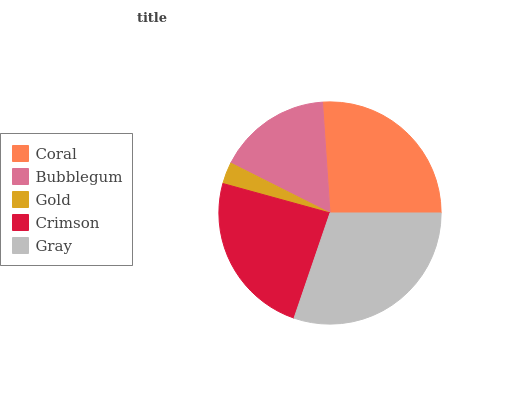Is Gold the minimum?
Answer yes or no. Yes. Is Gray the maximum?
Answer yes or no. Yes. Is Bubblegum the minimum?
Answer yes or no. No. Is Bubblegum the maximum?
Answer yes or no. No. Is Coral greater than Bubblegum?
Answer yes or no. Yes. Is Bubblegum less than Coral?
Answer yes or no. Yes. Is Bubblegum greater than Coral?
Answer yes or no. No. Is Coral less than Bubblegum?
Answer yes or no. No. Is Crimson the high median?
Answer yes or no. Yes. Is Crimson the low median?
Answer yes or no. Yes. Is Gray the high median?
Answer yes or no. No. Is Gold the low median?
Answer yes or no. No. 